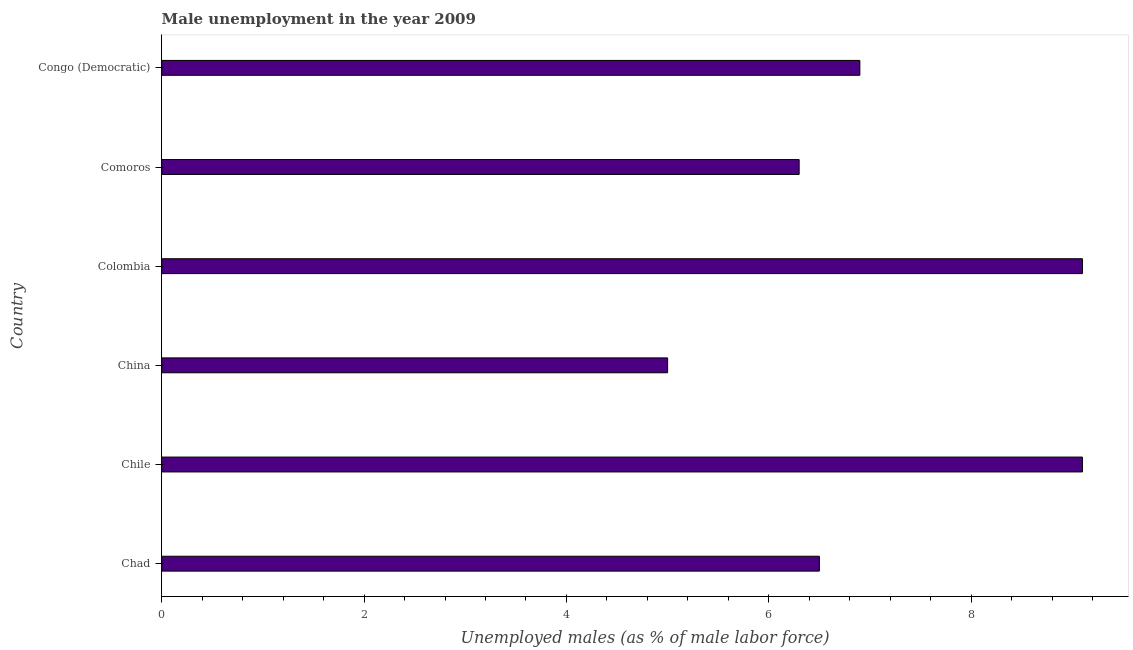What is the title of the graph?
Make the answer very short. Male unemployment in the year 2009. What is the label or title of the X-axis?
Your answer should be compact. Unemployed males (as % of male labor force). What is the label or title of the Y-axis?
Ensure brevity in your answer.  Country. Across all countries, what is the maximum unemployed males population?
Provide a succinct answer. 9.1. What is the sum of the unemployed males population?
Make the answer very short. 42.9. What is the difference between the unemployed males population in Colombia and Congo (Democratic)?
Make the answer very short. 2.2. What is the average unemployed males population per country?
Provide a succinct answer. 7.15. What is the median unemployed males population?
Keep it short and to the point. 6.7. What is the ratio of the unemployed males population in China to that in Colombia?
Give a very brief answer. 0.55. Is the difference between the unemployed males population in Chad and Comoros greater than the difference between any two countries?
Make the answer very short. No. What is the difference between the highest and the second highest unemployed males population?
Ensure brevity in your answer.  0. What is the difference between the highest and the lowest unemployed males population?
Your answer should be compact. 4.1. How many bars are there?
Offer a terse response. 6. What is the Unemployed males (as % of male labor force) in Chile?
Provide a succinct answer. 9.1. What is the Unemployed males (as % of male labor force) of Colombia?
Your answer should be compact. 9.1. What is the Unemployed males (as % of male labor force) of Comoros?
Make the answer very short. 6.3. What is the Unemployed males (as % of male labor force) of Congo (Democratic)?
Ensure brevity in your answer.  6.9. What is the difference between the Unemployed males (as % of male labor force) in Chad and Chile?
Keep it short and to the point. -2.6. What is the difference between the Unemployed males (as % of male labor force) in Chad and China?
Keep it short and to the point. 1.5. What is the difference between the Unemployed males (as % of male labor force) in Chad and Comoros?
Provide a succinct answer. 0.2. What is the difference between the Unemployed males (as % of male labor force) in Chad and Congo (Democratic)?
Give a very brief answer. -0.4. What is the difference between the Unemployed males (as % of male labor force) in Chile and China?
Your answer should be very brief. 4.1. What is the difference between the Unemployed males (as % of male labor force) in Chile and Colombia?
Your answer should be very brief. 0. What is the difference between the Unemployed males (as % of male labor force) in China and Colombia?
Provide a succinct answer. -4.1. What is the difference between the Unemployed males (as % of male labor force) in Comoros and Congo (Democratic)?
Your answer should be compact. -0.6. What is the ratio of the Unemployed males (as % of male labor force) in Chad to that in Chile?
Give a very brief answer. 0.71. What is the ratio of the Unemployed males (as % of male labor force) in Chad to that in China?
Your response must be concise. 1.3. What is the ratio of the Unemployed males (as % of male labor force) in Chad to that in Colombia?
Provide a short and direct response. 0.71. What is the ratio of the Unemployed males (as % of male labor force) in Chad to that in Comoros?
Provide a succinct answer. 1.03. What is the ratio of the Unemployed males (as % of male labor force) in Chad to that in Congo (Democratic)?
Your response must be concise. 0.94. What is the ratio of the Unemployed males (as % of male labor force) in Chile to that in China?
Ensure brevity in your answer.  1.82. What is the ratio of the Unemployed males (as % of male labor force) in Chile to that in Colombia?
Ensure brevity in your answer.  1. What is the ratio of the Unemployed males (as % of male labor force) in Chile to that in Comoros?
Give a very brief answer. 1.44. What is the ratio of the Unemployed males (as % of male labor force) in Chile to that in Congo (Democratic)?
Offer a terse response. 1.32. What is the ratio of the Unemployed males (as % of male labor force) in China to that in Colombia?
Provide a short and direct response. 0.55. What is the ratio of the Unemployed males (as % of male labor force) in China to that in Comoros?
Give a very brief answer. 0.79. What is the ratio of the Unemployed males (as % of male labor force) in China to that in Congo (Democratic)?
Your response must be concise. 0.72. What is the ratio of the Unemployed males (as % of male labor force) in Colombia to that in Comoros?
Offer a very short reply. 1.44. What is the ratio of the Unemployed males (as % of male labor force) in Colombia to that in Congo (Democratic)?
Your answer should be compact. 1.32. 